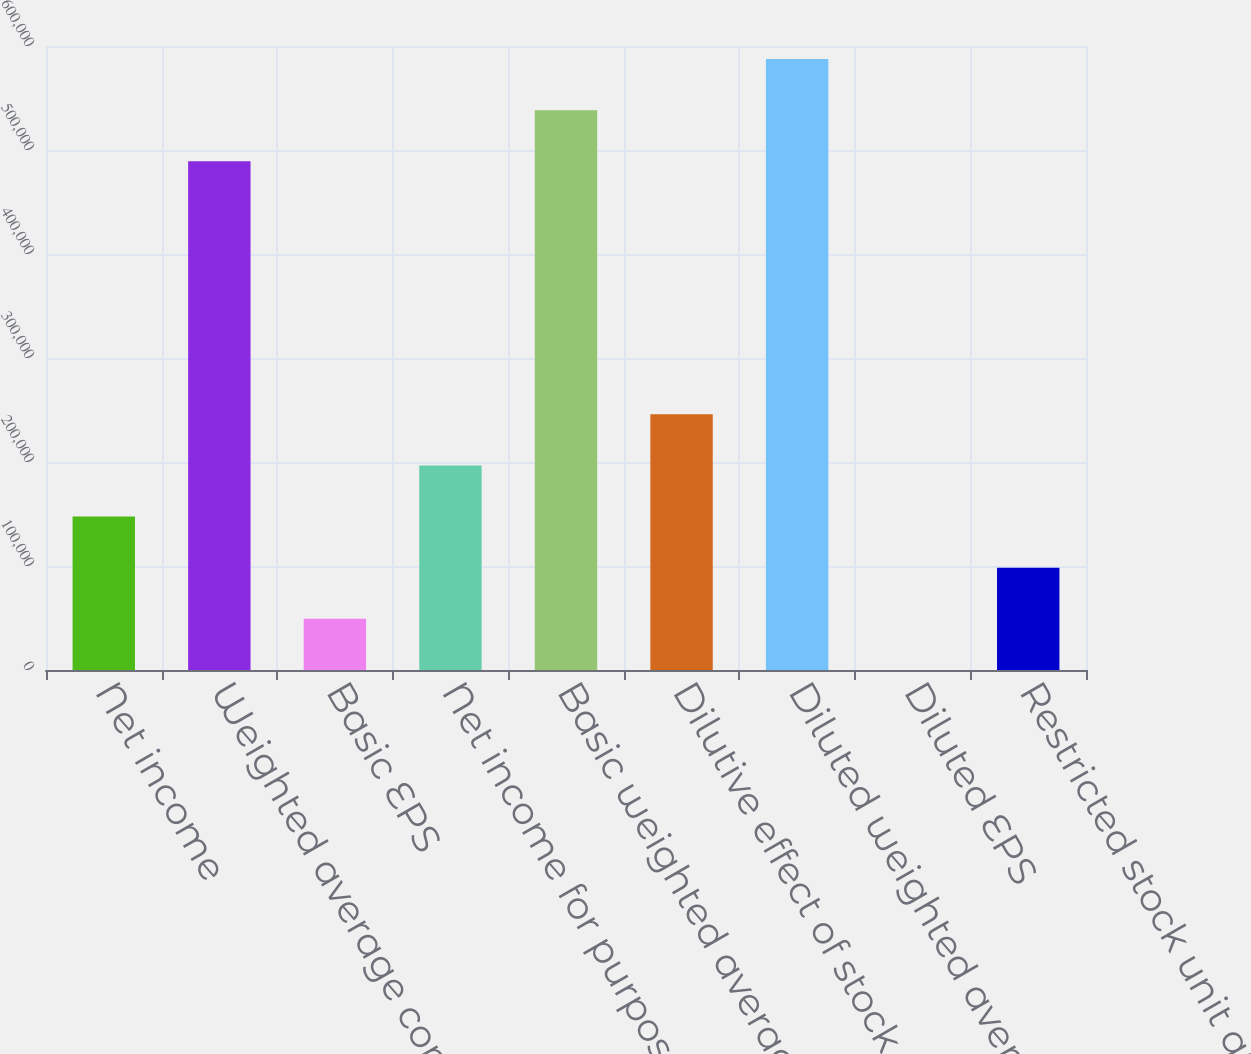<chart> <loc_0><loc_0><loc_500><loc_500><bar_chart><fcel>Net income<fcel>Weighted average common shares<fcel>Basic EPS<fcel>Net income for purposes of<fcel>Basic weighted average common<fcel>Dilutive effect of stock<fcel>Diluted weighted average<fcel>Diluted EPS<fcel>Restricted stock unit awards<nl><fcel>147509<fcel>489164<fcel>49171.6<fcel>196678<fcel>538333<fcel>245847<fcel>587502<fcel>2.61<fcel>98340.5<nl></chart> 